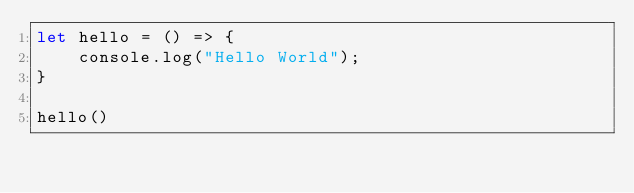<code> <loc_0><loc_0><loc_500><loc_500><_JavaScript_>let hello = () => {
    console.log("Hello World");
}

hello()
</code> 